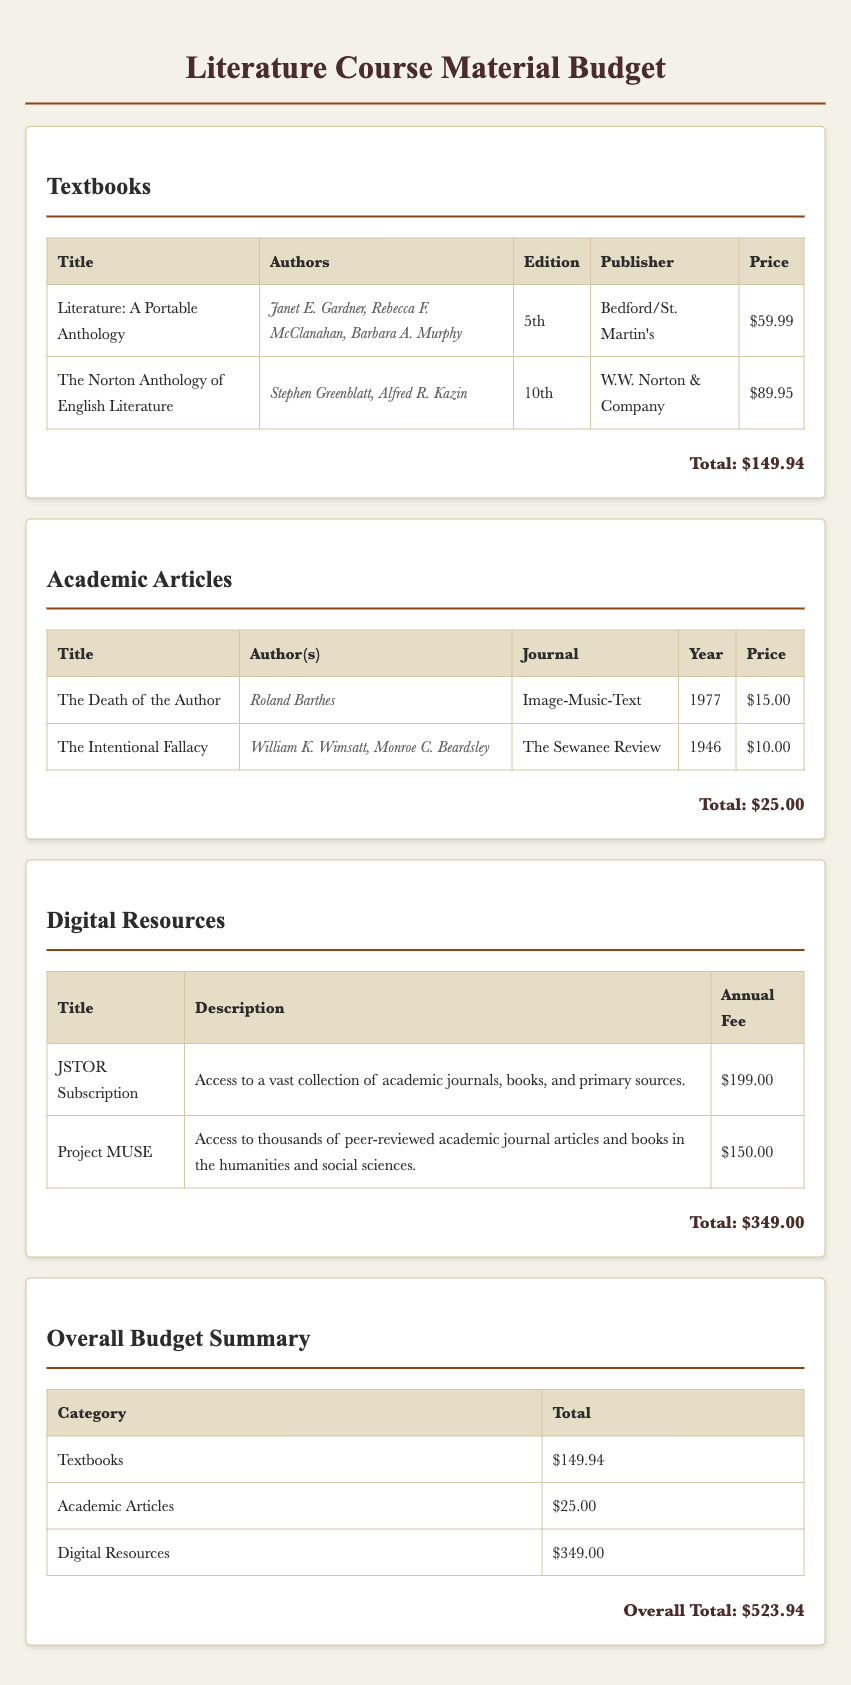What is the total cost of textbooks? The total cost of textbooks is provided in the document as a separate total under the Textbooks section.
Answer: $149.94 Who are the authors of "The Norton Anthology of English Literature"? The authors of this textbook are listed next to its title in the Textbooks section.
Answer: Stephen Greenblatt, Alfred R. Kazin What is the price of the JSTOR Subscription? The price of the JSTOR Subscription can be found in the Digital Resources section of the document.
Answer: $199.00 How many academic articles are listed in the budget? The number of academic articles is determined by counting the entries in the Academic Articles table.
Answer: 2 What is the annual fee for Project MUSE? The annual fee for Project MUSE is clearly stated in the Digital Resources section.
Answer: $150.00 What is the overall total of the budget? The overall total is presented in the Overall Budget Summary section, which sums all categories.
Answer: $523.94 Which article was published in 1946? The publication year of each article provides the information needed to identify this specific entry.
Answer: The Intentional Fallacy What is the total cost of academic articles? The total cost of academic articles is provided in its specific section, under a total line.
Answer: $25.00 What edition is "Literature: A Portable Anthology"? The edition of the textbook is listed in the corresponding row of the Textbooks table.
Answer: 5th 